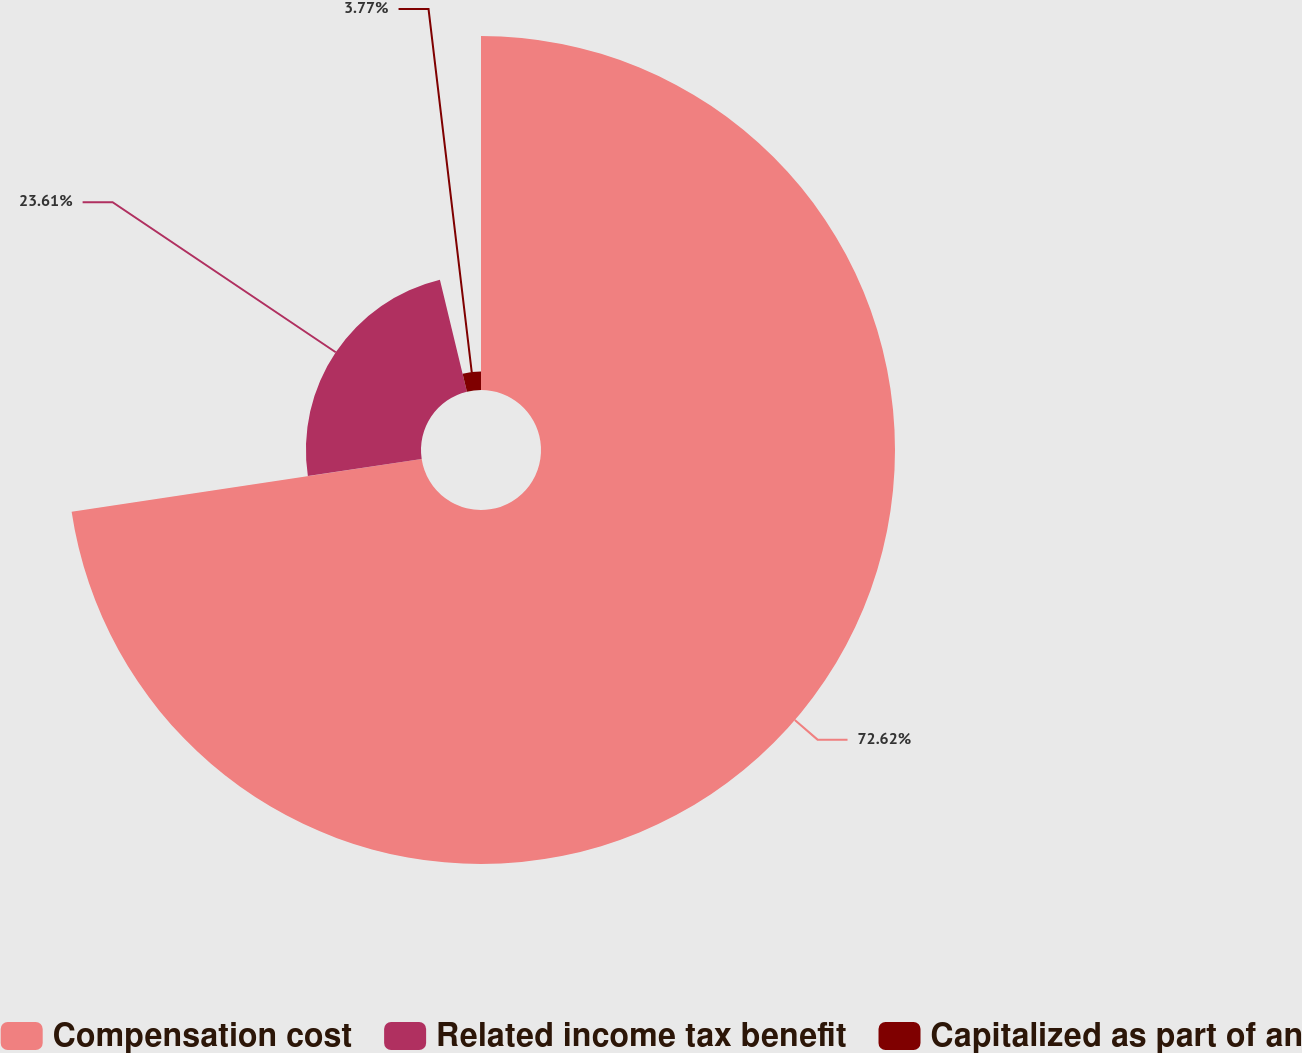Convert chart. <chart><loc_0><loc_0><loc_500><loc_500><pie_chart><fcel>Compensation cost<fcel>Related income tax benefit<fcel>Capitalized as part of an<nl><fcel>72.62%<fcel>23.61%<fcel>3.77%<nl></chart> 